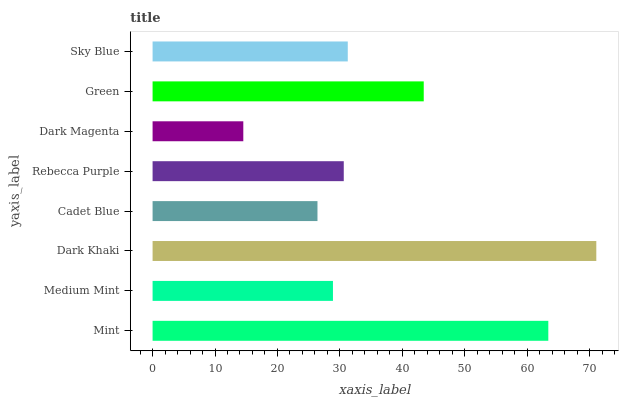Is Dark Magenta the minimum?
Answer yes or no. Yes. Is Dark Khaki the maximum?
Answer yes or no. Yes. Is Medium Mint the minimum?
Answer yes or no. No. Is Medium Mint the maximum?
Answer yes or no. No. Is Mint greater than Medium Mint?
Answer yes or no. Yes. Is Medium Mint less than Mint?
Answer yes or no. Yes. Is Medium Mint greater than Mint?
Answer yes or no. No. Is Mint less than Medium Mint?
Answer yes or no. No. Is Sky Blue the high median?
Answer yes or no. Yes. Is Rebecca Purple the low median?
Answer yes or no. Yes. Is Medium Mint the high median?
Answer yes or no. No. Is Dark Magenta the low median?
Answer yes or no. No. 